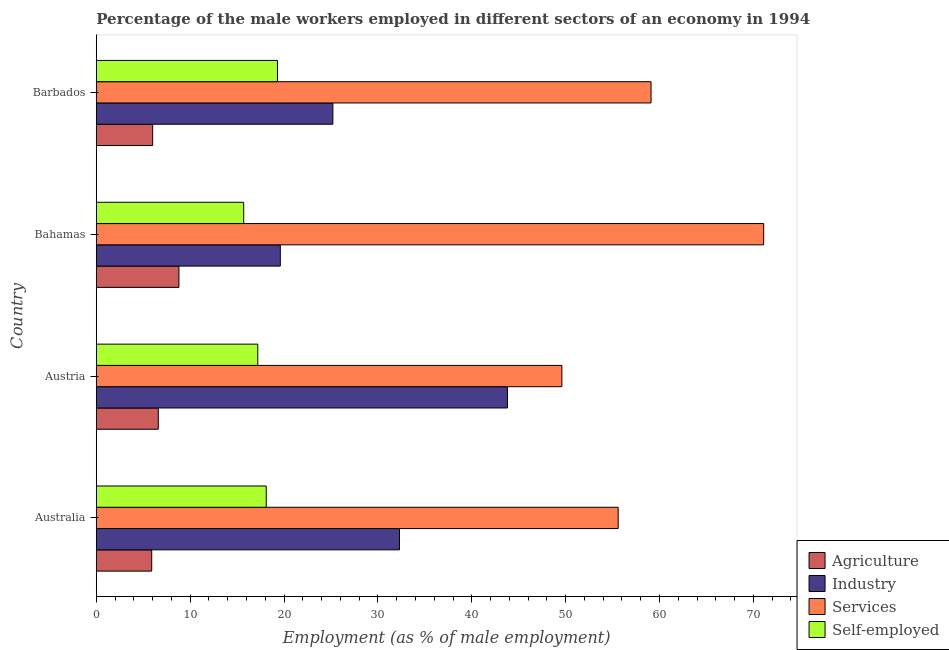How many different coloured bars are there?
Ensure brevity in your answer.  4. Are the number of bars on each tick of the Y-axis equal?
Give a very brief answer. Yes. How many bars are there on the 4th tick from the top?
Your response must be concise. 4. How many bars are there on the 3rd tick from the bottom?
Provide a short and direct response. 4. What is the label of the 1st group of bars from the top?
Make the answer very short. Barbados. In how many cases, is the number of bars for a given country not equal to the number of legend labels?
Provide a short and direct response. 0. Across all countries, what is the maximum percentage of male workers in industry?
Offer a very short reply. 43.8. Across all countries, what is the minimum percentage of male workers in industry?
Make the answer very short. 19.6. In which country was the percentage of male workers in agriculture maximum?
Ensure brevity in your answer.  Bahamas. In which country was the percentage of self employed male workers minimum?
Offer a terse response. Bahamas. What is the total percentage of male workers in agriculture in the graph?
Provide a succinct answer. 27.3. What is the difference between the percentage of male workers in industry in Austria and that in Bahamas?
Ensure brevity in your answer.  24.2. What is the difference between the percentage of male workers in industry in Austria and the percentage of self employed male workers in Barbados?
Your answer should be very brief. 24.5. What is the average percentage of male workers in industry per country?
Make the answer very short. 30.23. What is the difference between the percentage of male workers in industry and percentage of male workers in services in Barbados?
Your response must be concise. -33.9. In how many countries, is the percentage of male workers in industry greater than the average percentage of male workers in industry taken over all countries?
Your answer should be very brief. 2. Is it the case that in every country, the sum of the percentage of male workers in agriculture and percentage of self employed male workers is greater than the sum of percentage of male workers in services and percentage of male workers in industry?
Your answer should be compact. No. What does the 1st bar from the top in Australia represents?
Provide a succinct answer. Self-employed. What does the 3rd bar from the bottom in Bahamas represents?
Give a very brief answer. Services. Is it the case that in every country, the sum of the percentage of male workers in agriculture and percentage of male workers in industry is greater than the percentage of male workers in services?
Offer a terse response. No. What is the difference between two consecutive major ticks on the X-axis?
Your response must be concise. 10. What is the title of the graph?
Ensure brevity in your answer.  Percentage of the male workers employed in different sectors of an economy in 1994. Does "Revenue mobilization" appear as one of the legend labels in the graph?
Offer a very short reply. No. What is the label or title of the X-axis?
Keep it short and to the point. Employment (as % of male employment). What is the Employment (as % of male employment) in Agriculture in Australia?
Your response must be concise. 5.9. What is the Employment (as % of male employment) of Industry in Australia?
Your answer should be compact. 32.3. What is the Employment (as % of male employment) in Services in Australia?
Keep it short and to the point. 55.6. What is the Employment (as % of male employment) of Self-employed in Australia?
Make the answer very short. 18.1. What is the Employment (as % of male employment) in Agriculture in Austria?
Offer a terse response. 6.6. What is the Employment (as % of male employment) in Industry in Austria?
Offer a very short reply. 43.8. What is the Employment (as % of male employment) in Services in Austria?
Provide a succinct answer. 49.6. What is the Employment (as % of male employment) in Self-employed in Austria?
Ensure brevity in your answer.  17.2. What is the Employment (as % of male employment) in Agriculture in Bahamas?
Offer a terse response. 8.8. What is the Employment (as % of male employment) of Industry in Bahamas?
Give a very brief answer. 19.6. What is the Employment (as % of male employment) of Services in Bahamas?
Give a very brief answer. 71.1. What is the Employment (as % of male employment) of Self-employed in Bahamas?
Provide a short and direct response. 15.7. What is the Employment (as % of male employment) of Agriculture in Barbados?
Your response must be concise. 6. What is the Employment (as % of male employment) of Industry in Barbados?
Give a very brief answer. 25.2. What is the Employment (as % of male employment) of Services in Barbados?
Make the answer very short. 59.1. What is the Employment (as % of male employment) in Self-employed in Barbados?
Your answer should be compact. 19.3. Across all countries, what is the maximum Employment (as % of male employment) of Agriculture?
Ensure brevity in your answer.  8.8. Across all countries, what is the maximum Employment (as % of male employment) in Industry?
Ensure brevity in your answer.  43.8. Across all countries, what is the maximum Employment (as % of male employment) of Services?
Your answer should be compact. 71.1. Across all countries, what is the maximum Employment (as % of male employment) of Self-employed?
Keep it short and to the point. 19.3. Across all countries, what is the minimum Employment (as % of male employment) in Agriculture?
Your response must be concise. 5.9. Across all countries, what is the minimum Employment (as % of male employment) in Industry?
Give a very brief answer. 19.6. Across all countries, what is the minimum Employment (as % of male employment) of Services?
Offer a very short reply. 49.6. Across all countries, what is the minimum Employment (as % of male employment) of Self-employed?
Offer a terse response. 15.7. What is the total Employment (as % of male employment) in Agriculture in the graph?
Provide a succinct answer. 27.3. What is the total Employment (as % of male employment) of Industry in the graph?
Keep it short and to the point. 120.9. What is the total Employment (as % of male employment) of Services in the graph?
Ensure brevity in your answer.  235.4. What is the total Employment (as % of male employment) of Self-employed in the graph?
Provide a short and direct response. 70.3. What is the difference between the Employment (as % of male employment) in Industry in Australia and that in Austria?
Provide a short and direct response. -11.5. What is the difference between the Employment (as % of male employment) of Agriculture in Australia and that in Bahamas?
Your response must be concise. -2.9. What is the difference between the Employment (as % of male employment) in Services in Australia and that in Bahamas?
Offer a terse response. -15.5. What is the difference between the Employment (as % of male employment) of Industry in Australia and that in Barbados?
Give a very brief answer. 7.1. What is the difference between the Employment (as % of male employment) in Services in Australia and that in Barbados?
Provide a short and direct response. -3.5. What is the difference between the Employment (as % of male employment) of Self-employed in Australia and that in Barbados?
Provide a short and direct response. -1.2. What is the difference between the Employment (as % of male employment) of Industry in Austria and that in Bahamas?
Give a very brief answer. 24.2. What is the difference between the Employment (as % of male employment) in Services in Austria and that in Bahamas?
Give a very brief answer. -21.5. What is the difference between the Employment (as % of male employment) of Agriculture in Austria and that in Barbados?
Offer a very short reply. 0.6. What is the difference between the Employment (as % of male employment) of Industry in Austria and that in Barbados?
Your answer should be very brief. 18.6. What is the difference between the Employment (as % of male employment) in Self-employed in Austria and that in Barbados?
Provide a short and direct response. -2.1. What is the difference between the Employment (as % of male employment) of Agriculture in Bahamas and that in Barbados?
Your answer should be compact. 2.8. What is the difference between the Employment (as % of male employment) of Services in Bahamas and that in Barbados?
Your response must be concise. 12. What is the difference between the Employment (as % of male employment) in Self-employed in Bahamas and that in Barbados?
Give a very brief answer. -3.6. What is the difference between the Employment (as % of male employment) of Agriculture in Australia and the Employment (as % of male employment) of Industry in Austria?
Offer a very short reply. -37.9. What is the difference between the Employment (as % of male employment) of Agriculture in Australia and the Employment (as % of male employment) of Services in Austria?
Give a very brief answer. -43.7. What is the difference between the Employment (as % of male employment) in Agriculture in Australia and the Employment (as % of male employment) in Self-employed in Austria?
Keep it short and to the point. -11.3. What is the difference between the Employment (as % of male employment) of Industry in Australia and the Employment (as % of male employment) of Services in Austria?
Give a very brief answer. -17.3. What is the difference between the Employment (as % of male employment) of Industry in Australia and the Employment (as % of male employment) of Self-employed in Austria?
Offer a very short reply. 15.1. What is the difference between the Employment (as % of male employment) in Services in Australia and the Employment (as % of male employment) in Self-employed in Austria?
Keep it short and to the point. 38.4. What is the difference between the Employment (as % of male employment) in Agriculture in Australia and the Employment (as % of male employment) in Industry in Bahamas?
Your response must be concise. -13.7. What is the difference between the Employment (as % of male employment) of Agriculture in Australia and the Employment (as % of male employment) of Services in Bahamas?
Keep it short and to the point. -65.2. What is the difference between the Employment (as % of male employment) in Industry in Australia and the Employment (as % of male employment) in Services in Bahamas?
Ensure brevity in your answer.  -38.8. What is the difference between the Employment (as % of male employment) of Services in Australia and the Employment (as % of male employment) of Self-employed in Bahamas?
Give a very brief answer. 39.9. What is the difference between the Employment (as % of male employment) in Agriculture in Australia and the Employment (as % of male employment) in Industry in Barbados?
Keep it short and to the point. -19.3. What is the difference between the Employment (as % of male employment) of Agriculture in Australia and the Employment (as % of male employment) of Services in Barbados?
Provide a succinct answer. -53.2. What is the difference between the Employment (as % of male employment) of Industry in Australia and the Employment (as % of male employment) of Services in Barbados?
Offer a very short reply. -26.8. What is the difference between the Employment (as % of male employment) in Industry in Australia and the Employment (as % of male employment) in Self-employed in Barbados?
Provide a short and direct response. 13. What is the difference between the Employment (as % of male employment) of Services in Australia and the Employment (as % of male employment) of Self-employed in Barbados?
Keep it short and to the point. 36.3. What is the difference between the Employment (as % of male employment) in Agriculture in Austria and the Employment (as % of male employment) in Industry in Bahamas?
Offer a very short reply. -13. What is the difference between the Employment (as % of male employment) of Agriculture in Austria and the Employment (as % of male employment) of Services in Bahamas?
Give a very brief answer. -64.5. What is the difference between the Employment (as % of male employment) of Agriculture in Austria and the Employment (as % of male employment) of Self-employed in Bahamas?
Make the answer very short. -9.1. What is the difference between the Employment (as % of male employment) in Industry in Austria and the Employment (as % of male employment) in Services in Bahamas?
Ensure brevity in your answer.  -27.3. What is the difference between the Employment (as % of male employment) of Industry in Austria and the Employment (as % of male employment) of Self-employed in Bahamas?
Ensure brevity in your answer.  28.1. What is the difference between the Employment (as % of male employment) in Services in Austria and the Employment (as % of male employment) in Self-employed in Bahamas?
Offer a very short reply. 33.9. What is the difference between the Employment (as % of male employment) in Agriculture in Austria and the Employment (as % of male employment) in Industry in Barbados?
Your answer should be compact. -18.6. What is the difference between the Employment (as % of male employment) of Agriculture in Austria and the Employment (as % of male employment) of Services in Barbados?
Your answer should be compact. -52.5. What is the difference between the Employment (as % of male employment) of Agriculture in Austria and the Employment (as % of male employment) of Self-employed in Barbados?
Provide a short and direct response. -12.7. What is the difference between the Employment (as % of male employment) in Industry in Austria and the Employment (as % of male employment) in Services in Barbados?
Your response must be concise. -15.3. What is the difference between the Employment (as % of male employment) in Services in Austria and the Employment (as % of male employment) in Self-employed in Barbados?
Offer a very short reply. 30.3. What is the difference between the Employment (as % of male employment) in Agriculture in Bahamas and the Employment (as % of male employment) in Industry in Barbados?
Offer a very short reply. -16.4. What is the difference between the Employment (as % of male employment) in Agriculture in Bahamas and the Employment (as % of male employment) in Services in Barbados?
Ensure brevity in your answer.  -50.3. What is the difference between the Employment (as % of male employment) in Industry in Bahamas and the Employment (as % of male employment) in Services in Barbados?
Your answer should be very brief. -39.5. What is the difference between the Employment (as % of male employment) in Services in Bahamas and the Employment (as % of male employment) in Self-employed in Barbados?
Your answer should be very brief. 51.8. What is the average Employment (as % of male employment) in Agriculture per country?
Ensure brevity in your answer.  6.83. What is the average Employment (as % of male employment) in Industry per country?
Give a very brief answer. 30.23. What is the average Employment (as % of male employment) of Services per country?
Your answer should be compact. 58.85. What is the average Employment (as % of male employment) in Self-employed per country?
Offer a very short reply. 17.57. What is the difference between the Employment (as % of male employment) in Agriculture and Employment (as % of male employment) in Industry in Australia?
Your answer should be very brief. -26.4. What is the difference between the Employment (as % of male employment) in Agriculture and Employment (as % of male employment) in Services in Australia?
Provide a short and direct response. -49.7. What is the difference between the Employment (as % of male employment) in Agriculture and Employment (as % of male employment) in Self-employed in Australia?
Your answer should be very brief. -12.2. What is the difference between the Employment (as % of male employment) of Industry and Employment (as % of male employment) of Services in Australia?
Provide a succinct answer. -23.3. What is the difference between the Employment (as % of male employment) in Services and Employment (as % of male employment) in Self-employed in Australia?
Offer a terse response. 37.5. What is the difference between the Employment (as % of male employment) in Agriculture and Employment (as % of male employment) in Industry in Austria?
Offer a very short reply. -37.2. What is the difference between the Employment (as % of male employment) in Agriculture and Employment (as % of male employment) in Services in Austria?
Your answer should be compact. -43. What is the difference between the Employment (as % of male employment) in Agriculture and Employment (as % of male employment) in Self-employed in Austria?
Offer a very short reply. -10.6. What is the difference between the Employment (as % of male employment) of Industry and Employment (as % of male employment) of Self-employed in Austria?
Give a very brief answer. 26.6. What is the difference between the Employment (as % of male employment) of Services and Employment (as % of male employment) of Self-employed in Austria?
Ensure brevity in your answer.  32.4. What is the difference between the Employment (as % of male employment) in Agriculture and Employment (as % of male employment) in Services in Bahamas?
Your response must be concise. -62.3. What is the difference between the Employment (as % of male employment) of Industry and Employment (as % of male employment) of Services in Bahamas?
Offer a terse response. -51.5. What is the difference between the Employment (as % of male employment) of Services and Employment (as % of male employment) of Self-employed in Bahamas?
Provide a succinct answer. 55.4. What is the difference between the Employment (as % of male employment) in Agriculture and Employment (as % of male employment) in Industry in Barbados?
Keep it short and to the point. -19.2. What is the difference between the Employment (as % of male employment) of Agriculture and Employment (as % of male employment) of Services in Barbados?
Provide a succinct answer. -53.1. What is the difference between the Employment (as % of male employment) of Industry and Employment (as % of male employment) of Services in Barbados?
Keep it short and to the point. -33.9. What is the difference between the Employment (as % of male employment) in Industry and Employment (as % of male employment) in Self-employed in Barbados?
Provide a short and direct response. 5.9. What is the difference between the Employment (as % of male employment) in Services and Employment (as % of male employment) in Self-employed in Barbados?
Ensure brevity in your answer.  39.8. What is the ratio of the Employment (as % of male employment) in Agriculture in Australia to that in Austria?
Ensure brevity in your answer.  0.89. What is the ratio of the Employment (as % of male employment) in Industry in Australia to that in Austria?
Your answer should be very brief. 0.74. What is the ratio of the Employment (as % of male employment) in Services in Australia to that in Austria?
Keep it short and to the point. 1.12. What is the ratio of the Employment (as % of male employment) of Self-employed in Australia to that in Austria?
Provide a succinct answer. 1.05. What is the ratio of the Employment (as % of male employment) of Agriculture in Australia to that in Bahamas?
Your answer should be compact. 0.67. What is the ratio of the Employment (as % of male employment) of Industry in Australia to that in Bahamas?
Ensure brevity in your answer.  1.65. What is the ratio of the Employment (as % of male employment) of Services in Australia to that in Bahamas?
Provide a succinct answer. 0.78. What is the ratio of the Employment (as % of male employment) in Self-employed in Australia to that in Bahamas?
Your answer should be very brief. 1.15. What is the ratio of the Employment (as % of male employment) in Agriculture in Australia to that in Barbados?
Provide a succinct answer. 0.98. What is the ratio of the Employment (as % of male employment) in Industry in Australia to that in Barbados?
Your answer should be very brief. 1.28. What is the ratio of the Employment (as % of male employment) of Services in Australia to that in Barbados?
Offer a very short reply. 0.94. What is the ratio of the Employment (as % of male employment) in Self-employed in Australia to that in Barbados?
Provide a short and direct response. 0.94. What is the ratio of the Employment (as % of male employment) of Industry in Austria to that in Bahamas?
Your response must be concise. 2.23. What is the ratio of the Employment (as % of male employment) in Services in Austria to that in Bahamas?
Make the answer very short. 0.7. What is the ratio of the Employment (as % of male employment) in Self-employed in Austria to that in Bahamas?
Your answer should be very brief. 1.1. What is the ratio of the Employment (as % of male employment) in Agriculture in Austria to that in Barbados?
Make the answer very short. 1.1. What is the ratio of the Employment (as % of male employment) in Industry in Austria to that in Barbados?
Keep it short and to the point. 1.74. What is the ratio of the Employment (as % of male employment) of Services in Austria to that in Barbados?
Ensure brevity in your answer.  0.84. What is the ratio of the Employment (as % of male employment) in Self-employed in Austria to that in Barbados?
Offer a terse response. 0.89. What is the ratio of the Employment (as % of male employment) in Agriculture in Bahamas to that in Barbados?
Your response must be concise. 1.47. What is the ratio of the Employment (as % of male employment) in Services in Bahamas to that in Barbados?
Your response must be concise. 1.2. What is the ratio of the Employment (as % of male employment) in Self-employed in Bahamas to that in Barbados?
Make the answer very short. 0.81. What is the difference between the highest and the second highest Employment (as % of male employment) of Agriculture?
Offer a terse response. 2.2. What is the difference between the highest and the second highest Employment (as % of male employment) in Services?
Keep it short and to the point. 12. What is the difference between the highest and the second highest Employment (as % of male employment) of Self-employed?
Offer a terse response. 1.2. What is the difference between the highest and the lowest Employment (as % of male employment) of Industry?
Make the answer very short. 24.2. 